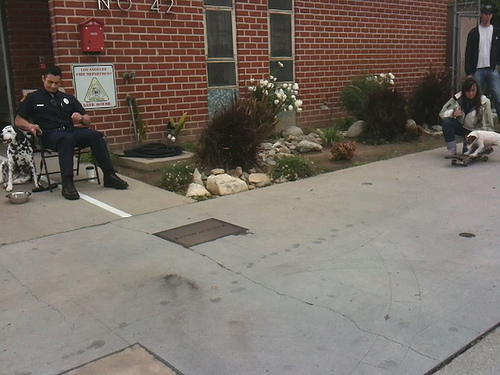<image>Where is the window? I am unsure where the window is located. It could be on a building, on a wall or behind flowers. What kind of bird is on the sidewalk? There is no bird on the sidewalk. What kind of bird is on the sidewalk? I don't know what kind of bird is on the sidewalk. There is no bird in the image. Where is the window? I am not sure where the window is. It can be seen on the building, behind flowers, or on the front of the building. 